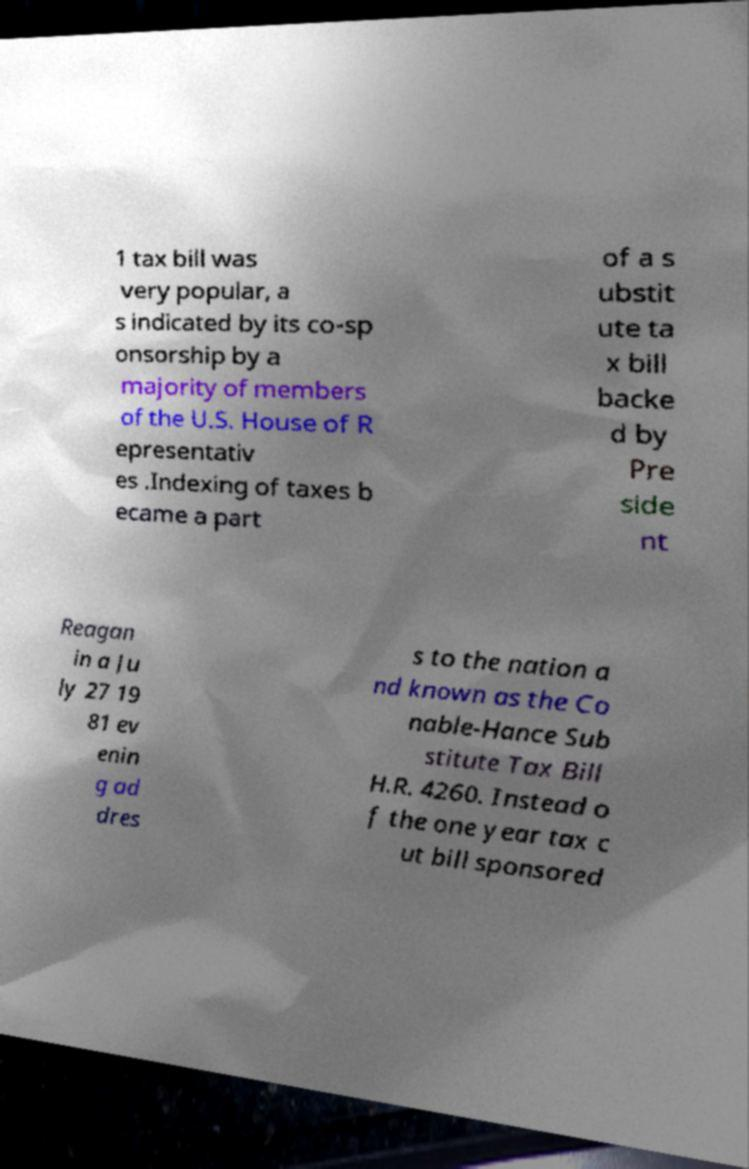There's text embedded in this image that I need extracted. Can you transcribe it verbatim? 1 tax bill was very popular, a s indicated by its co-sp onsorship by a majority of members of the U.S. House of R epresentativ es .Indexing of taxes b ecame a part of a s ubstit ute ta x bill backe d by Pre side nt Reagan in a Ju ly 27 19 81 ev enin g ad dres s to the nation a nd known as the Co nable-Hance Sub stitute Tax Bill H.R. 4260. Instead o f the one year tax c ut bill sponsored 